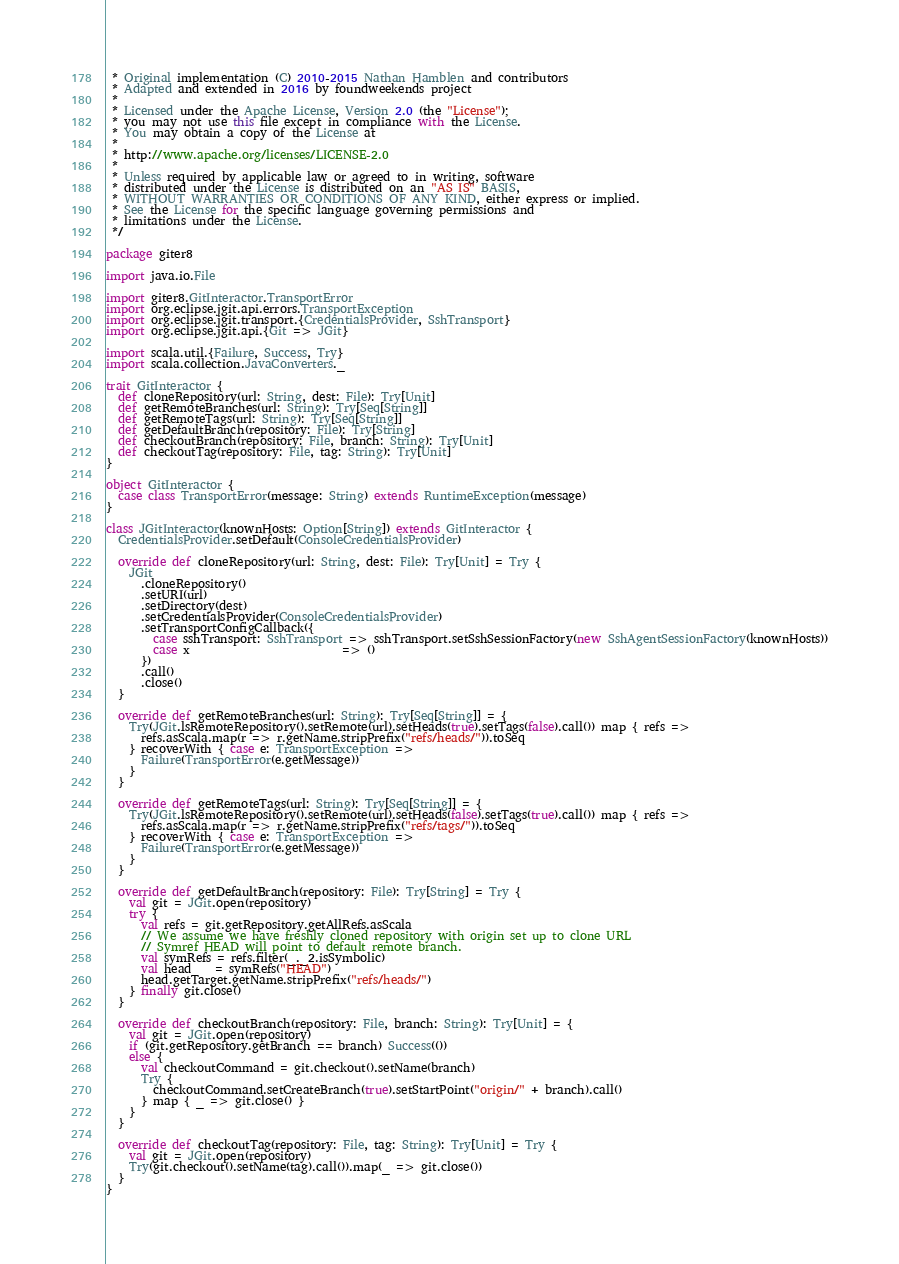<code> <loc_0><loc_0><loc_500><loc_500><_Scala_> * Original implementation (C) 2010-2015 Nathan Hamblen and contributors
 * Adapted and extended in 2016 by foundweekends project
 *
 * Licensed under the Apache License, Version 2.0 (the "License");
 * you may not use this file except in compliance with the License.
 * You may obtain a copy of the License at
 *
 * http://www.apache.org/licenses/LICENSE-2.0
 *
 * Unless required by applicable law or agreed to in writing, software
 * distributed under the License is distributed on an "AS IS" BASIS,
 * WITHOUT WARRANTIES OR CONDITIONS OF ANY KIND, either express or implied.
 * See the License for the specific language governing permissions and
 * limitations under the License.
 */

package giter8

import java.io.File

import giter8.GitInteractor.TransportError
import org.eclipse.jgit.api.errors.TransportException
import org.eclipse.jgit.transport.{CredentialsProvider, SshTransport}
import org.eclipse.jgit.api.{Git => JGit}

import scala.util.{Failure, Success, Try}
import scala.collection.JavaConverters._

trait GitInteractor {
  def cloneRepository(url: String, dest: File): Try[Unit]
  def getRemoteBranches(url: String): Try[Seq[String]]
  def getRemoteTags(url: String): Try[Seq[String]]
  def getDefaultBranch(repository: File): Try[String]
  def checkoutBranch(repository: File, branch: String): Try[Unit]
  def checkoutTag(repository: File, tag: String): Try[Unit]
}

object GitInteractor {
  case class TransportError(message: String) extends RuntimeException(message)
}

class JGitInteractor(knownHosts: Option[String]) extends GitInteractor {
  CredentialsProvider.setDefault(ConsoleCredentialsProvider)

  override def cloneRepository(url: String, dest: File): Try[Unit] = Try {
    JGit
      .cloneRepository()
      .setURI(url)
      .setDirectory(dest)
      .setCredentialsProvider(ConsoleCredentialsProvider)
      .setTransportConfigCallback({
        case sshTransport: SshTransport => sshTransport.setSshSessionFactory(new SshAgentSessionFactory(knownHosts))
        case x                          => ()
      })
      .call()
      .close()
  }

  override def getRemoteBranches(url: String): Try[Seq[String]] = {
    Try(JGit.lsRemoteRepository().setRemote(url).setHeads(true).setTags(false).call()) map { refs =>
      refs.asScala.map(r => r.getName.stripPrefix("refs/heads/")).toSeq
    } recoverWith { case e: TransportException =>
      Failure(TransportError(e.getMessage))
    }
  }

  override def getRemoteTags(url: String): Try[Seq[String]] = {
    Try(JGit.lsRemoteRepository().setRemote(url).setHeads(false).setTags(true).call()) map { refs =>
      refs.asScala.map(r => r.getName.stripPrefix("refs/tags/")).toSeq
    } recoverWith { case e: TransportException =>
      Failure(TransportError(e.getMessage))
    }
  }

  override def getDefaultBranch(repository: File): Try[String] = Try {
    val git = JGit.open(repository)
    try {
      val refs = git.getRepository.getAllRefs.asScala
      // We assume we have freshly cloned repository with origin set up to clone URL
      // Symref HEAD will point to default remote branch.
      val symRefs = refs.filter(_._2.isSymbolic)
      val head    = symRefs("HEAD")
      head.getTarget.getName.stripPrefix("refs/heads/")
    } finally git.close()
  }

  override def checkoutBranch(repository: File, branch: String): Try[Unit] = {
    val git = JGit.open(repository)
    if (git.getRepository.getBranch == branch) Success(())
    else {
      val checkoutCommand = git.checkout().setName(branch)
      Try {
        checkoutCommand.setCreateBranch(true).setStartPoint("origin/" + branch).call()
      } map { _ => git.close() }
    }
  }

  override def checkoutTag(repository: File, tag: String): Try[Unit] = Try {
    val git = JGit.open(repository)
    Try(git.checkout().setName(tag).call()).map(_ => git.close())
  }
}
</code> 